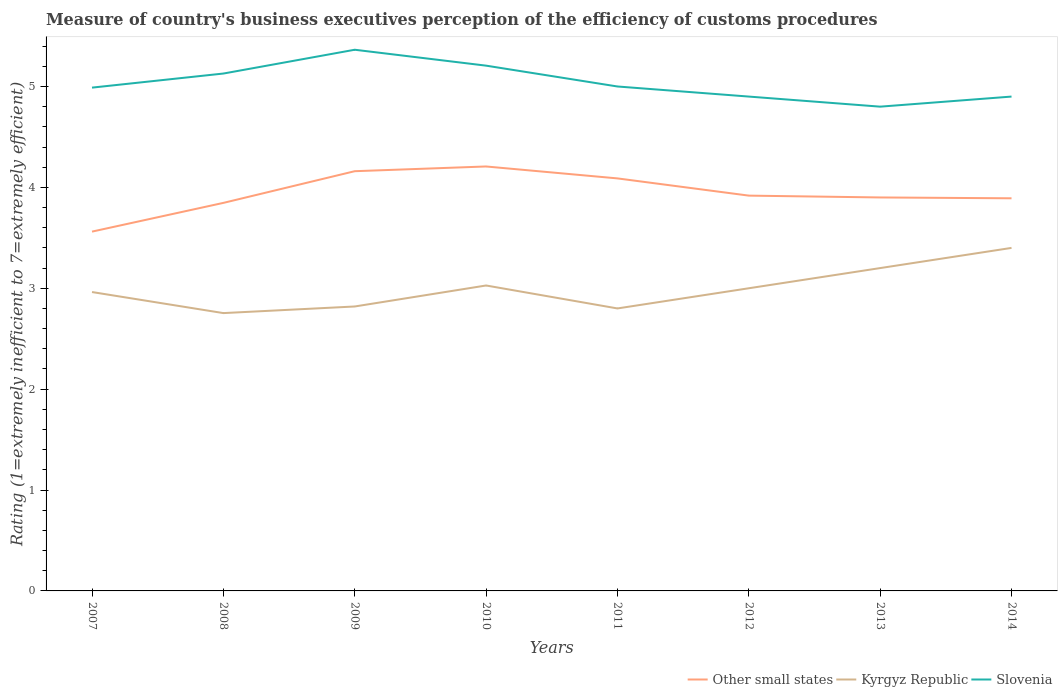How many different coloured lines are there?
Keep it short and to the point. 3. What is the total rating of the efficiency of customs procedure in Slovenia in the graph?
Keep it short and to the point. 0.31. What is the difference between the highest and the second highest rating of the efficiency of customs procedure in Other small states?
Provide a succinct answer. 0.65. Is the rating of the efficiency of customs procedure in Kyrgyz Republic strictly greater than the rating of the efficiency of customs procedure in Slovenia over the years?
Give a very brief answer. Yes. How many years are there in the graph?
Offer a very short reply. 8. Are the values on the major ticks of Y-axis written in scientific E-notation?
Provide a short and direct response. No. Does the graph contain any zero values?
Your answer should be very brief. No. Where does the legend appear in the graph?
Give a very brief answer. Bottom right. How are the legend labels stacked?
Offer a very short reply. Horizontal. What is the title of the graph?
Ensure brevity in your answer.  Measure of country's business executives perception of the efficiency of customs procedures. What is the label or title of the X-axis?
Provide a short and direct response. Years. What is the label or title of the Y-axis?
Provide a succinct answer. Rating (1=extremely inefficient to 7=extremely efficient). What is the Rating (1=extremely inefficient to 7=extremely efficient) of Other small states in 2007?
Your answer should be very brief. 3.56. What is the Rating (1=extremely inefficient to 7=extremely efficient) in Kyrgyz Republic in 2007?
Offer a terse response. 2.96. What is the Rating (1=extremely inefficient to 7=extremely efficient) in Slovenia in 2007?
Keep it short and to the point. 4.99. What is the Rating (1=extremely inefficient to 7=extremely efficient) in Other small states in 2008?
Provide a short and direct response. 3.85. What is the Rating (1=extremely inefficient to 7=extremely efficient) of Kyrgyz Republic in 2008?
Offer a terse response. 2.75. What is the Rating (1=extremely inefficient to 7=extremely efficient) of Slovenia in 2008?
Provide a short and direct response. 5.13. What is the Rating (1=extremely inefficient to 7=extremely efficient) of Other small states in 2009?
Your response must be concise. 4.16. What is the Rating (1=extremely inefficient to 7=extremely efficient) in Kyrgyz Republic in 2009?
Your answer should be compact. 2.82. What is the Rating (1=extremely inefficient to 7=extremely efficient) of Slovenia in 2009?
Make the answer very short. 5.36. What is the Rating (1=extremely inefficient to 7=extremely efficient) of Other small states in 2010?
Offer a terse response. 4.21. What is the Rating (1=extremely inefficient to 7=extremely efficient) of Kyrgyz Republic in 2010?
Your answer should be very brief. 3.03. What is the Rating (1=extremely inefficient to 7=extremely efficient) of Slovenia in 2010?
Give a very brief answer. 5.21. What is the Rating (1=extremely inefficient to 7=extremely efficient) in Other small states in 2011?
Give a very brief answer. 4.09. What is the Rating (1=extremely inefficient to 7=extremely efficient) in Kyrgyz Republic in 2011?
Offer a terse response. 2.8. What is the Rating (1=extremely inefficient to 7=extremely efficient) in Slovenia in 2011?
Give a very brief answer. 5. What is the Rating (1=extremely inefficient to 7=extremely efficient) in Other small states in 2012?
Your answer should be compact. 3.92. What is the Rating (1=extremely inefficient to 7=extremely efficient) of Slovenia in 2012?
Your response must be concise. 4.9. What is the Rating (1=extremely inefficient to 7=extremely efficient) in Other small states in 2013?
Keep it short and to the point. 3.9. What is the Rating (1=extremely inefficient to 7=extremely efficient) of Kyrgyz Republic in 2013?
Keep it short and to the point. 3.2. What is the Rating (1=extremely inefficient to 7=extremely efficient) of Slovenia in 2013?
Provide a succinct answer. 4.8. What is the Rating (1=extremely inefficient to 7=extremely efficient) of Other small states in 2014?
Keep it short and to the point. 3.89. Across all years, what is the maximum Rating (1=extremely inefficient to 7=extremely efficient) in Other small states?
Offer a very short reply. 4.21. Across all years, what is the maximum Rating (1=extremely inefficient to 7=extremely efficient) in Kyrgyz Republic?
Ensure brevity in your answer.  3.4. Across all years, what is the maximum Rating (1=extremely inefficient to 7=extremely efficient) of Slovenia?
Keep it short and to the point. 5.36. Across all years, what is the minimum Rating (1=extremely inefficient to 7=extremely efficient) in Other small states?
Make the answer very short. 3.56. Across all years, what is the minimum Rating (1=extremely inefficient to 7=extremely efficient) in Kyrgyz Republic?
Your answer should be very brief. 2.75. What is the total Rating (1=extremely inefficient to 7=extremely efficient) of Other small states in the graph?
Provide a short and direct response. 31.57. What is the total Rating (1=extremely inefficient to 7=extremely efficient) in Kyrgyz Republic in the graph?
Give a very brief answer. 23.96. What is the total Rating (1=extremely inefficient to 7=extremely efficient) of Slovenia in the graph?
Offer a terse response. 40.29. What is the difference between the Rating (1=extremely inefficient to 7=extremely efficient) in Other small states in 2007 and that in 2008?
Give a very brief answer. -0.28. What is the difference between the Rating (1=extremely inefficient to 7=extremely efficient) of Kyrgyz Republic in 2007 and that in 2008?
Provide a succinct answer. 0.21. What is the difference between the Rating (1=extremely inefficient to 7=extremely efficient) of Slovenia in 2007 and that in 2008?
Give a very brief answer. -0.14. What is the difference between the Rating (1=extremely inefficient to 7=extremely efficient) in Other small states in 2007 and that in 2009?
Your answer should be very brief. -0.6. What is the difference between the Rating (1=extremely inefficient to 7=extremely efficient) in Kyrgyz Republic in 2007 and that in 2009?
Make the answer very short. 0.14. What is the difference between the Rating (1=extremely inefficient to 7=extremely efficient) of Slovenia in 2007 and that in 2009?
Your response must be concise. -0.38. What is the difference between the Rating (1=extremely inefficient to 7=extremely efficient) of Other small states in 2007 and that in 2010?
Offer a terse response. -0.65. What is the difference between the Rating (1=extremely inefficient to 7=extremely efficient) in Kyrgyz Republic in 2007 and that in 2010?
Offer a very short reply. -0.06. What is the difference between the Rating (1=extremely inefficient to 7=extremely efficient) of Slovenia in 2007 and that in 2010?
Your response must be concise. -0.22. What is the difference between the Rating (1=extremely inefficient to 7=extremely efficient) in Other small states in 2007 and that in 2011?
Provide a succinct answer. -0.53. What is the difference between the Rating (1=extremely inefficient to 7=extremely efficient) of Kyrgyz Republic in 2007 and that in 2011?
Provide a short and direct response. 0.16. What is the difference between the Rating (1=extremely inefficient to 7=extremely efficient) in Slovenia in 2007 and that in 2011?
Offer a terse response. -0.01. What is the difference between the Rating (1=extremely inefficient to 7=extremely efficient) of Other small states in 2007 and that in 2012?
Provide a succinct answer. -0.36. What is the difference between the Rating (1=extremely inefficient to 7=extremely efficient) in Kyrgyz Republic in 2007 and that in 2012?
Offer a terse response. -0.04. What is the difference between the Rating (1=extremely inefficient to 7=extremely efficient) of Slovenia in 2007 and that in 2012?
Your answer should be very brief. 0.09. What is the difference between the Rating (1=extremely inefficient to 7=extremely efficient) of Other small states in 2007 and that in 2013?
Offer a very short reply. -0.34. What is the difference between the Rating (1=extremely inefficient to 7=extremely efficient) of Kyrgyz Republic in 2007 and that in 2013?
Make the answer very short. -0.24. What is the difference between the Rating (1=extremely inefficient to 7=extremely efficient) in Slovenia in 2007 and that in 2013?
Your answer should be very brief. 0.19. What is the difference between the Rating (1=extremely inefficient to 7=extremely efficient) of Other small states in 2007 and that in 2014?
Provide a succinct answer. -0.33. What is the difference between the Rating (1=extremely inefficient to 7=extremely efficient) in Kyrgyz Republic in 2007 and that in 2014?
Ensure brevity in your answer.  -0.44. What is the difference between the Rating (1=extremely inefficient to 7=extremely efficient) of Slovenia in 2007 and that in 2014?
Ensure brevity in your answer.  0.09. What is the difference between the Rating (1=extremely inefficient to 7=extremely efficient) in Other small states in 2008 and that in 2009?
Your answer should be very brief. -0.31. What is the difference between the Rating (1=extremely inefficient to 7=extremely efficient) of Kyrgyz Republic in 2008 and that in 2009?
Keep it short and to the point. -0.07. What is the difference between the Rating (1=extremely inefficient to 7=extremely efficient) in Slovenia in 2008 and that in 2009?
Keep it short and to the point. -0.24. What is the difference between the Rating (1=extremely inefficient to 7=extremely efficient) of Other small states in 2008 and that in 2010?
Provide a succinct answer. -0.36. What is the difference between the Rating (1=extremely inefficient to 7=extremely efficient) of Kyrgyz Republic in 2008 and that in 2010?
Offer a terse response. -0.27. What is the difference between the Rating (1=extremely inefficient to 7=extremely efficient) in Slovenia in 2008 and that in 2010?
Offer a very short reply. -0.08. What is the difference between the Rating (1=extremely inefficient to 7=extremely efficient) in Other small states in 2008 and that in 2011?
Your response must be concise. -0.24. What is the difference between the Rating (1=extremely inefficient to 7=extremely efficient) in Kyrgyz Republic in 2008 and that in 2011?
Provide a short and direct response. -0.05. What is the difference between the Rating (1=extremely inefficient to 7=extremely efficient) in Slovenia in 2008 and that in 2011?
Offer a very short reply. 0.13. What is the difference between the Rating (1=extremely inefficient to 7=extremely efficient) in Other small states in 2008 and that in 2012?
Offer a very short reply. -0.07. What is the difference between the Rating (1=extremely inefficient to 7=extremely efficient) in Kyrgyz Republic in 2008 and that in 2012?
Keep it short and to the point. -0.25. What is the difference between the Rating (1=extremely inefficient to 7=extremely efficient) of Slovenia in 2008 and that in 2012?
Give a very brief answer. 0.23. What is the difference between the Rating (1=extremely inefficient to 7=extremely efficient) in Other small states in 2008 and that in 2013?
Offer a terse response. -0.05. What is the difference between the Rating (1=extremely inefficient to 7=extremely efficient) in Kyrgyz Republic in 2008 and that in 2013?
Provide a short and direct response. -0.45. What is the difference between the Rating (1=extremely inefficient to 7=extremely efficient) in Slovenia in 2008 and that in 2013?
Your answer should be very brief. 0.33. What is the difference between the Rating (1=extremely inefficient to 7=extremely efficient) in Other small states in 2008 and that in 2014?
Give a very brief answer. -0.05. What is the difference between the Rating (1=extremely inefficient to 7=extremely efficient) of Kyrgyz Republic in 2008 and that in 2014?
Your response must be concise. -0.65. What is the difference between the Rating (1=extremely inefficient to 7=extremely efficient) in Slovenia in 2008 and that in 2014?
Keep it short and to the point. 0.23. What is the difference between the Rating (1=extremely inefficient to 7=extremely efficient) of Other small states in 2009 and that in 2010?
Ensure brevity in your answer.  -0.05. What is the difference between the Rating (1=extremely inefficient to 7=extremely efficient) of Kyrgyz Republic in 2009 and that in 2010?
Your answer should be compact. -0.21. What is the difference between the Rating (1=extremely inefficient to 7=extremely efficient) in Slovenia in 2009 and that in 2010?
Your response must be concise. 0.16. What is the difference between the Rating (1=extremely inefficient to 7=extremely efficient) in Other small states in 2009 and that in 2011?
Your response must be concise. 0.07. What is the difference between the Rating (1=extremely inefficient to 7=extremely efficient) in Kyrgyz Republic in 2009 and that in 2011?
Your response must be concise. 0.02. What is the difference between the Rating (1=extremely inefficient to 7=extremely efficient) of Slovenia in 2009 and that in 2011?
Ensure brevity in your answer.  0.36. What is the difference between the Rating (1=extremely inefficient to 7=extremely efficient) in Other small states in 2009 and that in 2012?
Ensure brevity in your answer.  0.24. What is the difference between the Rating (1=extremely inefficient to 7=extremely efficient) in Kyrgyz Republic in 2009 and that in 2012?
Ensure brevity in your answer.  -0.18. What is the difference between the Rating (1=extremely inefficient to 7=extremely efficient) in Slovenia in 2009 and that in 2012?
Offer a terse response. 0.46. What is the difference between the Rating (1=extremely inefficient to 7=extremely efficient) of Other small states in 2009 and that in 2013?
Your answer should be very brief. 0.26. What is the difference between the Rating (1=extremely inefficient to 7=extremely efficient) of Kyrgyz Republic in 2009 and that in 2013?
Keep it short and to the point. -0.38. What is the difference between the Rating (1=extremely inefficient to 7=extremely efficient) of Slovenia in 2009 and that in 2013?
Offer a terse response. 0.56. What is the difference between the Rating (1=extremely inefficient to 7=extremely efficient) of Other small states in 2009 and that in 2014?
Keep it short and to the point. 0.27. What is the difference between the Rating (1=extremely inefficient to 7=extremely efficient) in Kyrgyz Republic in 2009 and that in 2014?
Offer a terse response. -0.58. What is the difference between the Rating (1=extremely inefficient to 7=extremely efficient) of Slovenia in 2009 and that in 2014?
Provide a short and direct response. 0.46. What is the difference between the Rating (1=extremely inefficient to 7=extremely efficient) of Other small states in 2010 and that in 2011?
Ensure brevity in your answer.  0.12. What is the difference between the Rating (1=extremely inefficient to 7=extremely efficient) of Kyrgyz Republic in 2010 and that in 2011?
Ensure brevity in your answer.  0.23. What is the difference between the Rating (1=extremely inefficient to 7=extremely efficient) in Slovenia in 2010 and that in 2011?
Your answer should be very brief. 0.21. What is the difference between the Rating (1=extremely inefficient to 7=extremely efficient) in Other small states in 2010 and that in 2012?
Make the answer very short. 0.29. What is the difference between the Rating (1=extremely inefficient to 7=extremely efficient) of Kyrgyz Republic in 2010 and that in 2012?
Your answer should be compact. 0.03. What is the difference between the Rating (1=extremely inefficient to 7=extremely efficient) in Slovenia in 2010 and that in 2012?
Your answer should be very brief. 0.31. What is the difference between the Rating (1=extremely inefficient to 7=extremely efficient) in Other small states in 2010 and that in 2013?
Provide a short and direct response. 0.31. What is the difference between the Rating (1=extremely inefficient to 7=extremely efficient) in Kyrgyz Republic in 2010 and that in 2013?
Offer a terse response. -0.17. What is the difference between the Rating (1=extremely inefficient to 7=extremely efficient) of Slovenia in 2010 and that in 2013?
Offer a very short reply. 0.41. What is the difference between the Rating (1=extremely inefficient to 7=extremely efficient) of Other small states in 2010 and that in 2014?
Make the answer very short. 0.32. What is the difference between the Rating (1=extremely inefficient to 7=extremely efficient) of Kyrgyz Republic in 2010 and that in 2014?
Offer a terse response. -0.37. What is the difference between the Rating (1=extremely inefficient to 7=extremely efficient) in Slovenia in 2010 and that in 2014?
Offer a very short reply. 0.31. What is the difference between the Rating (1=extremely inefficient to 7=extremely efficient) of Other small states in 2011 and that in 2012?
Make the answer very short. 0.17. What is the difference between the Rating (1=extremely inefficient to 7=extremely efficient) in Other small states in 2011 and that in 2013?
Keep it short and to the point. 0.19. What is the difference between the Rating (1=extremely inefficient to 7=extremely efficient) in Other small states in 2011 and that in 2014?
Your answer should be compact. 0.2. What is the difference between the Rating (1=extremely inefficient to 7=extremely efficient) in Kyrgyz Republic in 2011 and that in 2014?
Provide a succinct answer. -0.6. What is the difference between the Rating (1=extremely inefficient to 7=extremely efficient) of Slovenia in 2011 and that in 2014?
Your answer should be very brief. 0.1. What is the difference between the Rating (1=extremely inefficient to 7=extremely efficient) of Other small states in 2012 and that in 2013?
Make the answer very short. 0.02. What is the difference between the Rating (1=extremely inefficient to 7=extremely efficient) in Slovenia in 2012 and that in 2013?
Offer a terse response. 0.1. What is the difference between the Rating (1=extremely inefficient to 7=extremely efficient) of Other small states in 2012 and that in 2014?
Your answer should be very brief. 0.03. What is the difference between the Rating (1=extremely inefficient to 7=extremely efficient) of Slovenia in 2012 and that in 2014?
Make the answer very short. 0. What is the difference between the Rating (1=extremely inefficient to 7=extremely efficient) in Other small states in 2013 and that in 2014?
Your answer should be very brief. 0.01. What is the difference between the Rating (1=extremely inefficient to 7=extremely efficient) of Slovenia in 2013 and that in 2014?
Your answer should be very brief. -0.1. What is the difference between the Rating (1=extremely inefficient to 7=extremely efficient) in Other small states in 2007 and the Rating (1=extremely inefficient to 7=extremely efficient) in Kyrgyz Republic in 2008?
Provide a succinct answer. 0.81. What is the difference between the Rating (1=extremely inefficient to 7=extremely efficient) of Other small states in 2007 and the Rating (1=extremely inefficient to 7=extremely efficient) of Slovenia in 2008?
Offer a very short reply. -1.57. What is the difference between the Rating (1=extremely inefficient to 7=extremely efficient) in Kyrgyz Republic in 2007 and the Rating (1=extremely inefficient to 7=extremely efficient) in Slovenia in 2008?
Ensure brevity in your answer.  -2.17. What is the difference between the Rating (1=extremely inefficient to 7=extremely efficient) in Other small states in 2007 and the Rating (1=extremely inefficient to 7=extremely efficient) in Kyrgyz Republic in 2009?
Give a very brief answer. 0.74. What is the difference between the Rating (1=extremely inefficient to 7=extremely efficient) of Other small states in 2007 and the Rating (1=extremely inefficient to 7=extremely efficient) of Slovenia in 2009?
Your answer should be very brief. -1.8. What is the difference between the Rating (1=extremely inefficient to 7=extremely efficient) of Kyrgyz Republic in 2007 and the Rating (1=extremely inefficient to 7=extremely efficient) of Slovenia in 2009?
Offer a very short reply. -2.4. What is the difference between the Rating (1=extremely inefficient to 7=extremely efficient) of Other small states in 2007 and the Rating (1=extremely inefficient to 7=extremely efficient) of Kyrgyz Republic in 2010?
Make the answer very short. 0.53. What is the difference between the Rating (1=extremely inefficient to 7=extremely efficient) of Other small states in 2007 and the Rating (1=extremely inefficient to 7=extremely efficient) of Slovenia in 2010?
Provide a short and direct response. -1.65. What is the difference between the Rating (1=extremely inefficient to 7=extremely efficient) in Kyrgyz Republic in 2007 and the Rating (1=extremely inefficient to 7=extremely efficient) in Slovenia in 2010?
Your answer should be very brief. -2.24. What is the difference between the Rating (1=extremely inefficient to 7=extremely efficient) of Other small states in 2007 and the Rating (1=extremely inefficient to 7=extremely efficient) of Kyrgyz Republic in 2011?
Offer a terse response. 0.76. What is the difference between the Rating (1=extremely inefficient to 7=extremely efficient) in Other small states in 2007 and the Rating (1=extremely inefficient to 7=extremely efficient) in Slovenia in 2011?
Make the answer very short. -1.44. What is the difference between the Rating (1=extremely inefficient to 7=extremely efficient) in Kyrgyz Republic in 2007 and the Rating (1=extremely inefficient to 7=extremely efficient) in Slovenia in 2011?
Ensure brevity in your answer.  -2.04. What is the difference between the Rating (1=extremely inefficient to 7=extremely efficient) in Other small states in 2007 and the Rating (1=extremely inefficient to 7=extremely efficient) in Kyrgyz Republic in 2012?
Make the answer very short. 0.56. What is the difference between the Rating (1=extremely inefficient to 7=extremely efficient) of Other small states in 2007 and the Rating (1=extremely inefficient to 7=extremely efficient) of Slovenia in 2012?
Give a very brief answer. -1.34. What is the difference between the Rating (1=extremely inefficient to 7=extremely efficient) of Kyrgyz Republic in 2007 and the Rating (1=extremely inefficient to 7=extremely efficient) of Slovenia in 2012?
Keep it short and to the point. -1.94. What is the difference between the Rating (1=extremely inefficient to 7=extremely efficient) of Other small states in 2007 and the Rating (1=extremely inefficient to 7=extremely efficient) of Kyrgyz Republic in 2013?
Offer a terse response. 0.36. What is the difference between the Rating (1=extremely inefficient to 7=extremely efficient) in Other small states in 2007 and the Rating (1=extremely inefficient to 7=extremely efficient) in Slovenia in 2013?
Give a very brief answer. -1.24. What is the difference between the Rating (1=extremely inefficient to 7=extremely efficient) in Kyrgyz Republic in 2007 and the Rating (1=extremely inefficient to 7=extremely efficient) in Slovenia in 2013?
Provide a succinct answer. -1.84. What is the difference between the Rating (1=extremely inefficient to 7=extremely efficient) in Other small states in 2007 and the Rating (1=extremely inefficient to 7=extremely efficient) in Kyrgyz Republic in 2014?
Provide a succinct answer. 0.16. What is the difference between the Rating (1=extremely inefficient to 7=extremely efficient) of Other small states in 2007 and the Rating (1=extremely inefficient to 7=extremely efficient) of Slovenia in 2014?
Offer a very short reply. -1.34. What is the difference between the Rating (1=extremely inefficient to 7=extremely efficient) in Kyrgyz Republic in 2007 and the Rating (1=extremely inefficient to 7=extremely efficient) in Slovenia in 2014?
Ensure brevity in your answer.  -1.94. What is the difference between the Rating (1=extremely inefficient to 7=extremely efficient) of Other small states in 2008 and the Rating (1=extremely inefficient to 7=extremely efficient) of Kyrgyz Republic in 2009?
Your response must be concise. 1.03. What is the difference between the Rating (1=extremely inefficient to 7=extremely efficient) of Other small states in 2008 and the Rating (1=extremely inefficient to 7=extremely efficient) of Slovenia in 2009?
Provide a succinct answer. -1.52. What is the difference between the Rating (1=extremely inefficient to 7=extremely efficient) of Kyrgyz Republic in 2008 and the Rating (1=extremely inefficient to 7=extremely efficient) of Slovenia in 2009?
Your answer should be very brief. -2.61. What is the difference between the Rating (1=extremely inefficient to 7=extremely efficient) of Other small states in 2008 and the Rating (1=extremely inefficient to 7=extremely efficient) of Kyrgyz Republic in 2010?
Provide a succinct answer. 0.82. What is the difference between the Rating (1=extremely inefficient to 7=extremely efficient) in Other small states in 2008 and the Rating (1=extremely inefficient to 7=extremely efficient) in Slovenia in 2010?
Keep it short and to the point. -1.36. What is the difference between the Rating (1=extremely inefficient to 7=extremely efficient) of Kyrgyz Republic in 2008 and the Rating (1=extremely inefficient to 7=extremely efficient) of Slovenia in 2010?
Keep it short and to the point. -2.45. What is the difference between the Rating (1=extremely inefficient to 7=extremely efficient) in Other small states in 2008 and the Rating (1=extremely inefficient to 7=extremely efficient) in Kyrgyz Republic in 2011?
Offer a very short reply. 1.05. What is the difference between the Rating (1=extremely inefficient to 7=extremely efficient) in Other small states in 2008 and the Rating (1=extremely inefficient to 7=extremely efficient) in Slovenia in 2011?
Provide a succinct answer. -1.15. What is the difference between the Rating (1=extremely inefficient to 7=extremely efficient) in Kyrgyz Republic in 2008 and the Rating (1=extremely inefficient to 7=extremely efficient) in Slovenia in 2011?
Provide a succinct answer. -2.25. What is the difference between the Rating (1=extremely inefficient to 7=extremely efficient) in Other small states in 2008 and the Rating (1=extremely inefficient to 7=extremely efficient) in Kyrgyz Republic in 2012?
Provide a short and direct response. 0.85. What is the difference between the Rating (1=extremely inefficient to 7=extremely efficient) of Other small states in 2008 and the Rating (1=extremely inefficient to 7=extremely efficient) of Slovenia in 2012?
Your response must be concise. -1.05. What is the difference between the Rating (1=extremely inefficient to 7=extremely efficient) in Kyrgyz Republic in 2008 and the Rating (1=extremely inefficient to 7=extremely efficient) in Slovenia in 2012?
Your response must be concise. -2.15. What is the difference between the Rating (1=extremely inefficient to 7=extremely efficient) of Other small states in 2008 and the Rating (1=extremely inefficient to 7=extremely efficient) of Kyrgyz Republic in 2013?
Provide a succinct answer. 0.65. What is the difference between the Rating (1=extremely inefficient to 7=extremely efficient) in Other small states in 2008 and the Rating (1=extremely inefficient to 7=extremely efficient) in Slovenia in 2013?
Give a very brief answer. -0.95. What is the difference between the Rating (1=extremely inefficient to 7=extremely efficient) in Kyrgyz Republic in 2008 and the Rating (1=extremely inefficient to 7=extremely efficient) in Slovenia in 2013?
Your answer should be very brief. -2.05. What is the difference between the Rating (1=extremely inefficient to 7=extremely efficient) in Other small states in 2008 and the Rating (1=extremely inefficient to 7=extremely efficient) in Kyrgyz Republic in 2014?
Your response must be concise. 0.45. What is the difference between the Rating (1=extremely inefficient to 7=extremely efficient) of Other small states in 2008 and the Rating (1=extremely inefficient to 7=extremely efficient) of Slovenia in 2014?
Ensure brevity in your answer.  -1.05. What is the difference between the Rating (1=extremely inefficient to 7=extremely efficient) of Kyrgyz Republic in 2008 and the Rating (1=extremely inefficient to 7=extremely efficient) of Slovenia in 2014?
Ensure brevity in your answer.  -2.15. What is the difference between the Rating (1=extremely inefficient to 7=extremely efficient) in Other small states in 2009 and the Rating (1=extremely inefficient to 7=extremely efficient) in Kyrgyz Republic in 2010?
Your answer should be compact. 1.13. What is the difference between the Rating (1=extremely inefficient to 7=extremely efficient) in Other small states in 2009 and the Rating (1=extremely inefficient to 7=extremely efficient) in Slovenia in 2010?
Make the answer very short. -1.05. What is the difference between the Rating (1=extremely inefficient to 7=extremely efficient) of Kyrgyz Republic in 2009 and the Rating (1=extremely inefficient to 7=extremely efficient) of Slovenia in 2010?
Give a very brief answer. -2.39. What is the difference between the Rating (1=extremely inefficient to 7=extremely efficient) of Other small states in 2009 and the Rating (1=extremely inefficient to 7=extremely efficient) of Kyrgyz Republic in 2011?
Give a very brief answer. 1.36. What is the difference between the Rating (1=extremely inefficient to 7=extremely efficient) in Other small states in 2009 and the Rating (1=extremely inefficient to 7=extremely efficient) in Slovenia in 2011?
Offer a terse response. -0.84. What is the difference between the Rating (1=extremely inefficient to 7=extremely efficient) of Kyrgyz Republic in 2009 and the Rating (1=extremely inefficient to 7=extremely efficient) of Slovenia in 2011?
Provide a succinct answer. -2.18. What is the difference between the Rating (1=extremely inefficient to 7=extremely efficient) of Other small states in 2009 and the Rating (1=extremely inefficient to 7=extremely efficient) of Kyrgyz Republic in 2012?
Provide a succinct answer. 1.16. What is the difference between the Rating (1=extremely inefficient to 7=extremely efficient) of Other small states in 2009 and the Rating (1=extremely inefficient to 7=extremely efficient) of Slovenia in 2012?
Keep it short and to the point. -0.74. What is the difference between the Rating (1=extremely inefficient to 7=extremely efficient) of Kyrgyz Republic in 2009 and the Rating (1=extremely inefficient to 7=extremely efficient) of Slovenia in 2012?
Offer a very short reply. -2.08. What is the difference between the Rating (1=extremely inefficient to 7=extremely efficient) in Other small states in 2009 and the Rating (1=extremely inefficient to 7=extremely efficient) in Kyrgyz Republic in 2013?
Provide a succinct answer. 0.96. What is the difference between the Rating (1=extremely inefficient to 7=extremely efficient) of Other small states in 2009 and the Rating (1=extremely inefficient to 7=extremely efficient) of Slovenia in 2013?
Your answer should be compact. -0.64. What is the difference between the Rating (1=extremely inefficient to 7=extremely efficient) in Kyrgyz Republic in 2009 and the Rating (1=extremely inefficient to 7=extremely efficient) in Slovenia in 2013?
Provide a succinct answer. -1.98. What is the difference between the Rating (1=extremely inefficient to 7=extremely efficient) in Other small states in 2009 and the Rating (1=extremely inefficient to 7=extremely efficient) in Kyrgyz Republic in 2014?
Your answer should be very brief. 0.76. What is the difference between the Rating (1=extremely inefficient to 7=extremely efficient) in Other small states in 2009 and the Rating (1=extremely inefficient to 7=extremely efficient) in Slovenia in 2014?
Your response must be concise. -0.74. What is the difference between the Rating (1=extremely inefficient to 7=extremely efficient) in Kyrgyz Republic in 2009 and the Rating (1=extremely inefficient to 7=extremely efficient) in Slovenia in 2014?
Give a very brief answer. -2.08. What is the difference between the Rating (1=extremely inefficient to 7=extremely efficient) of Other small states in 2010 and the Rating (1=extremely inefficient to 7=extremely efficient) of Kyrgyz Republic in 2011?
Your answer should be compact. 1.41. What is the difference between the Rating (1=extremely inefficient to 7=extremely efficient) of Other small states in 2010 and the Rating (1=extremely inefficient to 7=extremely efficient) of Slovenia in 2011?
Offer a very short reply. -0.79. What is the difference between the Rating (1=extremely inefficient to 7=extremely efficient) in Kyrgyz Republic in 2010 and the Rating (1=extremely inefficient to 7=extremely efficient) in Slovenia in 2011?
Make the answer very short. -1.97. What is the difference between the Rating (1=extremely inefficient to 7=extremely efficient) in Other small states in 2010 and the Rating (1=extremely inefficient to 7=extremely efficient) in Kyrgyz Republic in 2012?
Your answer should be compact. 1.21. What is the difference between the Rating (1=extremely inefficient to 7=extremely efficient) in Other small states in 2010 and the Rating (1=extremely inefficient to 7=extremely efficient) in Slovenia in 2012?
Provide a succinct answer. -0.69. What is the difference between the Rating (1=extremely inefficient to 7=extremely efficient) of Kyrgyz Republic in 2010 and the Rating (1=extremely inefficient to 7=extremely efficient) of Slovenia in 2012?
Your answer should be very brief. -1.87. What is the difference between the Rating (1=extremely inefficient to 7=extremely efficient) in Other small states in 2010 and the Rating (1=extremely inefficient to 7=extremely efficient) in Kyrgyz Republic in 2013?
Offer a terse response. 1.01. What is the difference between the Rating (1=extremely inefficient to 7=extremely efficient) of Other small states in 2010 and the Rating (1=extremely inefficient to 7=extremely efficient) of Slovenia in 2013?
Your answer should be very brief. -0.59. What is the difference between the Rating (1=extremely inefficient to 7=extremely efficient) of Kyrgyz Republic in 2010 and the Rating (1=extremely inefficient to 7=extremely efficient) of Slovenia in 2013?
Your answer should be compact. -1.77. What is the difference between the Rating (1=extremely inefficient to 7=extremely efficient) in Other small states in 2010 and the Rating (1=extremely inefficient to 7=extremely efficient) in Kyrgyz Republic in 2014?
Give a very brief answer. 0.81. What is the difference between the Rating (1=extremely inefficient to 7=extremely efficient) of Other small states in 2010 and the Rating (1=extremely inefficient to 7=extremely efficient) of Slovenia in 2014?
Provide a short and direct response. -0.69. What is the difference between the Rating (1=extremely inefficient to 7=extremely efficient) of Kyrgyz Republic in 2010 and the Rating (1=extremely inefficient to 7=extremely efficient) of Slovenia in 2014?
Your answer should be very brief. -1.87. What is the difference between the Rating (1=extremely inefficient to 7=extremely efficient) of Other small states in 2011 and the Rating (1=extremely inefficient to 7=extremely efficient) of Kyrgyz Republic in 2012?
Ensure brevity in your answer.  1.09. What is the difference between the Rating (1=extremely inefficient to 7=extremely efficient) of Other small states in 2011 and the Rating (1=extremely inefficient to 7=extremely efficient) of Slovenia in 2012?
Provide a succinct answer. -0.81. What is the difference between the Rating (1=extremely inefficient to 7=extremely efficient) of Other small states in 2011 and the Rating (1=extremely inefficient to 7=extremely efficient) of Slovenia in 2013?
Ensure brevity in your answer.  -0.71. What is the difference between the Rating (1=extremely inefficient to 7=extremely efficient) of Other small states in 2011 and the Rating (1=extremely inefficient to 7=extremely efficient) of Kyrgyz Republic in 2014?
Give a very brief answer. 0.69. What is the difference between the Rating (1=extremely inefficient to 7=extremely efficient) of Other small states in 2011 and the Rating (1=extremely inefficient to 7=extremely efficient) of Slovenia in 2014?
Ensure brevity in your answer.  -0.81. What is the difference between the Rating (1=extremely inefficient to 7=extremely efficient) of Other small states in 2012 and the Rating (1=extremely inefficient to 7=extremely efficient) of Kyrgyz Republic in 2013?
Your answer should be compact. 0.72. What is the difference between the Rating (1=extremely inefficient to 7=extremely efficient) of Other small states in 2012 and the Rating (1=extremely inefficient to 7=extremely efficient) of Slovenia in 2013?
Your answer should be very brief. -0.88. What is the difference between the Rating (1=extremely inefficient to 7=extremely efficient) of Kyrgyz Republic in 2012 and the Rating (1=extremely inefficient to 7=extremely efficient) of Slovenia in 2013?
Offer a terse response. -1.8. What is the difference between the Rating (1=extremely inefficient to 7=extremely efficient) of Other small states in 2012 and the Rating (1=extremely inefficient to 7=extremely efficient) of Kyrgyz Republic in 2014?
Offer a very short reply. 0.52. What is the difference between the Rating (1=extremely inefficient to 7=extremely efficient) of Other small states in 2012 and the Rating (1=extremely inefficient to 7=extremely efficient) of Slovenia in 2014?
Your answer should be compact. -0.98. What is the difference between the Rating (1=extremely inefficient to 7=extremely efficient) in Kyrgyz Republic in 2012 and the Rating (1=extremely inefficient to 7=extremely efficient) in Slovenia in 2014?
Keep it short and to the point. -1.9. What is the difference between the Rating (1=extremely inefficient to 7=extremely efficient) in Other small states in 2013 and the Rating (1=extremely inefficient to 7=extremely efficient) in Kyrgyz Republic in 2014?
Ensure brevity in your answer.  0.5. What is the difference between the Rating (1=extremely inefficient to 7=extremely efficient) in Other small states in 2013 and the Rating (1=extremely inefficient to 7=extremely efficient) in Slovenia in 2014?
Offer a terse response. -1. What is the difference between the Rating (1=extremely inefficient to 7=extremely efficient) in Kyrgyz Republic in 2013 and the Rating (1=extremely inefficient to 7=extremely efficient) in Slovenia in 2014?
Give a very brief answer. -1.7. What is the average Rating (1=extremely inefficient to 7=extremely efficient) of Other small states per year?
Keep it short and to the point. 3.95. What is the average Rating (1=extremely inefficient to 7=extremely efficient) in Kyrgyz Republic per year?
Provide a short and direct response. 3. What is the average Rating (1=extremely inefficient to 7=extremely efficient) of Slovenia per year?
Your response must be concise. 5.04. In the year 2007, what is the difference between the Rating (1=extremely inefficient to 7=extremely efficient) of Other small states and Rating (1=extremely inefficient to 7=extremely efficient) of Kyrgyz Republic?
Provide a succinct answer. 0.6. In the year 2007, what is the difference between the Rating (1=extremely inefficient to 7=extremely efficient) in Other small states and Rating (1=extremely inefficient to 7=extremely efficient) in Slovenia?
Offer a terse response. -1.43. In the year 2007, what is the difference between the Rating (1=extremely inefficient to 7=extremely efficient) of Kyrgyz Republic and Rating (1=extremely inefficient to 7=extremely efficient) of Slovenia?
Ensure brevity in your answer.  -2.03. In the year 2008, what is the difference between the Rating (1=extremely inefficient to 7=extremely efficient) of Other small states and Rating (1=extremely inefficient to 7=extremely efficient) of Kyrgyz Republic?
Your answer should be very brief. 1.09. In the year 2008, what is the difference between the Rating (1=extremely inefficient to 7=extremely efficient) in Other small states and Rating (1=extremely inefficient to 7=extremely efficient) in Slovenia?
Provide a succinct answer. -1.28. In the year 2008, what is the difference between the Rating (1=extremely inefficient to 7=extremely efficient) of Kyrgyz Republic and Rating (1=extremely inefficient to 7=extremely efficient) of Slovenia?
Provide a short and direct response. -2.37. In the year 2009, what is the difference between the Rating (1=extremely inefficient to 7=extremely efficient) in Other small states and Rating (1=extremely inefficient to 7=extremely efficient) in Kyrgyz Republic?
Provide a succinct answer. 1.34. In the year 2009, what is the difference between the Rating (1=extremely inefficient to 7=extremely efficient) of Other small states and Rating (1=extremely inefficient to 7=extremely efficient) of Slovenia?
Offer a terse response. -1.2. In the year 2009, what is the difference between the Rating (1=extremely inefficient to 7=extremely efficient) of Kyrgyz Republic and Rating (1=extremely inefficient to 7=extremely efficient) of Slovenia?
Your response must be concise. -2.54. In the year 2010, what is the difference between the Rating (1=extremely inefficient to 7=extremely efficient) in Other small states and Rating (1=extremely inefficient to 7=extremely efficient) in Kyrgyz Republic?
Provide a succinct answer. 1.18. In the year 2010, what is the difference between the Rating (1=extremely inefficient to 7=extremely efficient) of Other small states and Rating (1=extremely inefficient to 7=extremely efficient) of Slovenia?
Make the answer very short. -1. In the year 2010, what is the difference between the Rating (1=extremely inefficient to 7=extremely efficient) in Kyrgyz Republic and Rating (1=extremely inefficient to 7=extremely efficient) in Slovenia?
Provide a succinct answer. -2.18. In the year 2011, what is the difference between the Rating (1=extremely inefficient to 7=extremely efficient) of Other small states and Rating (1=extremely inefficient to 7=extremely efficient) of Kyrgyz Republic?
Offer a terse response. 1.29. In the year 2011, what is the difference between the Rating (1=extremely inefficient to 7=extremely efficient) of Other small states and Rating (1=extremely inefficient to 7=extremely efficient) of Slovenia?
Make the answer very short. -0.91. In the year 2012, what is the difference between the Rating (1=extremely inefficient to 7=extremely efficient) in Other small states and Rating (1=extremely inefficient to 7=extremely efficient) in Kyrgyz Republic?
Keep it short and to the point. 0.92. In the year 2012, what is the difference between the Rating (1=extremely inefficient to 7=extremely efficient) in Other small states and Rating (1=extremely inefficient to 7=extremely efficient) in Slovenia?
Your response must be concise. -0.98. In the year 2013, what is the difference between the Rating (1=extremely inefficient to 7=extremely efficient) in Other small states and Rating (1=extremely inefficient to 7=extremely efficient) in Kyrgyz Republic?
Your answer should be very brief. 0.7. In the year 2013, what is the difference between the Rating (1=extremely inefficient to 7=extremely efficient) of Kyrgyz Republic and Rating (1=extremely inefficient to 7=extremely efficient) of Slovenia?
Your response must be concise. -1.6. In the year 2014, what is the difference between the Rating (1=extremely inefficient to 7=extremely efficient) in Other small states and Rating (1=extremely inefficient to 7=extremely efficient) in Kyrgyz Republic?
Your response must be concise. 0.49. In the year 2014, what is the difference between the Rating (1=extremely inefficient to 7=extremely efficient) of Other small states and Rating (1=extremely inefficient to 7=extremely efficient) of Slovenia?
Ensure brevity in your answer.  -1.01. What is the ratio of the Rating (1=extremely inefficient to 7=extremely efficient) in Other small states in 2007 to that in 2008?
Your response must be concise. 0.93. What is the ratio of the Rating (1=extremely inefficient to 7=extremely efficient) of Kyrgyz Republic in 2007 to that in 2008?
Offer a very short reply. 1.08. What is the ratio of the Rating (1=extremely inefficient to 7=extremely efficient) of Slovenia in 2007 to that in 2008?
Offer a very short reply. 0.97. What is the ratio of the Rating (1=extremely inefficient to 7=extremely efficient) of Other small states in 2007 to that in 2009?
Your response must be concise. 0.86. What is the ratio of the Rating (1=extremely inefficient to 7=extremely efficient) in Kyrgyz Republic in 2007 to that in 2009?
Provide a short and direct response. 1.05. What is the ratio of the Rating (1=extremely inefficient to 7=extremely efficient) of Other small states in 2007 to that in 2010?
Provide a succinct answer. 0.85. What is the ratio of the Rating (1=extremely inefficient to 7=extremely efficient) of Kyrgyz Republic in 2007 to that in 2010?
Provide a succinct answer. 0.98. What is the ratio of the Rating (1=extremely inefficient to 7=extremely efficient) of Slovenia in 2007 to that in 2010?
Make the answer very short. 0.96. What is the ratio of the Rating (1=extremely inefficient to 7=extremely efficient) of Other small states in 2007 to that in 2011?
Offer a very short reply. 0.87. What is the ratio of the Rating (1=extremely inefficient to 7=extremely efficient) in Kyrgyz Republic in 2007 to that in 2011?
Offer a very short reply. 1.06. What is the ratio of the Rating (1=extremely inefficient to 7=extremely efficient) in Slovenia in 2007 to that in 2011?
Your response must be concise. 1. What is the ratio of the Rating (1=extremely inefficient to 7=extremely efficient) in Other small states in 2007 to that in 2012?
Provide a short and direct response. 0.91. What is the ratio of the Rating (1=extremely inefficient to 7=extremely efficient) in Kyrgyz Republic in 2007 to that in 2012?
Provide a short and direct response. 0.99. What is the ratio of the Rating (1=extremely inefficient to 7=extremely efficient) of Slovenia in 2007 to that in 2012?
Make the answer very short. 1.02. What is the ratio of the Rating (1=extremely inefficient to 7=extremely efficient) in Other small states in 2007 to that in 2013?
Make the answer very short. 0.91. What is the ratio of the Rating (1=extremely inefficient to 7=extremely efficient) in Kyrgyz Republic in 2007 to that in 2013?
Give a very brief answer. 0.93. What is the ratio of the Rating (1=extremely inefficient to 7=extremely efficient) in Slovenia in 2007 to that in 2013?
Your answer should be compact. 1.04. What is the ratio of the Rating (1=extremely inefficient to 7=extremely efficient) of Other small states in 2007 to that in 2014?
Provide a succinct answer. 0.92. What is the ratio of the Rating (1=extremely inefficient to 7=extremely efficient) of Kyrgyz Republic in 2007 to that in 2014?
Your answer should be very brief. 0.87. What is the ratio of the Rating (1=extremely inefficient to 7=extremely efficient) in Slovenia in 2007 to that in 2014?
Offer a terse response. 1.02. What is the ratio of the Rating (1=extremely inefficient to 7=extremely efficient) in Other small states in 2008 to that in 2009?
Give a very brief answer. 0.92. What is the ratio of the Rating (1=extremely inefficient to 7=extremely efficient) of Kyrgyz Republic in 2008 to that in 2009?
Offer a terse response. 0.98. What is the ratio of the Rating (1=extremely inefficient to 7=extremely efficient) of Slovenia in 2008 to that in 2009?
Keep it short and to the point. 0.96. What is the ratio of the Rating (1=extremely inefficient to 7=extremely efficient) of Other small states in 2008 to that in 2010?
Your answer should be compact. 0.91. What is the ratio of the Rating (1=extremely inefficient to 7=extremely efficient) in Kyrgyz Republic in 2008 to that in 2010?
Your answer should be compact. 0.91. What is the ratio of the Rating (1=extremely inefficient to 7=extremely efficient) of Slovenia in 2008 to that in 2010?
Make the answer very short. 0.98. What is the ratio of the Rating (1=extremely inefficient to 7=extremely efficient) of Other small states in 2008 to that in 2011?
Give a very brief answer. 0.94. What is the ratio of the Rating (1=extremely inefficient to 7=extremely efficient) in Kyrgyz Republic in 2008 to that in 2011?
Your answer should be very brief. 0.98. What is the ratio of the Rating (1=extremely inefficient to 7=extremely efficient) of Slovenia in 2008 to that in 2011?
Your answer should be compact. 1.03. What is the ratio of the Rating (1=extremely inefficient to 7=extremely efficient) in Other small states in 2008 to that in 2012?
Your answer should be compact. 0.98. What is the ratio of the Rating (1=extremely inefficient to 7=extremely efficient) in Kyrgyz Republic in 2008 to that in 2012?
Make the answer very short. 0.92. What is the ratio of the Rating (1=extremely inefficient to 7=extremely efficient) in Slovenia in 2008 to that in 2012?
Provide a succinct answer. 1.05. What is the ratio of the Rating (1=extremely inefficient to 7=extremely efficient) in Other small states in 2008 to that in 2013?
Your answer should be compact. 0.99. What is the ratio of the Rating (1=extremely inefficient to 7=extremely efficient) in Kyrgyz Republic in 2008 to that in 2013?
Make the answer very short. 0.86. What is the ratio of the Rating (1=extremely inefficient to 7=extremely efficient) in Slovenia in 2008 to that in 2013?
Offer a very short reply. 1.07. What is the ratio of the Rating (1=extremely inefficient to 7=extremely efficient) in Other small states in 2008 to that in 2014?
Ensure brevity in your answer.  0.99. What is the ratio of the Rating (1=extremely inefficient to 7=extremely efficient) of Kyrgyz Republic in 2008 to that in 2014?
Give a very brief answer. 0.81. What is the ratio of the Rating (1=extremely inefficient to 7=extremely efficient) in Slovenia in 2008 to that in 2014?
Your answer should be very brief. 1.05. What is the ratio of the Rating (1=extremely inefficient to 7=extremely efficient) of Other small states in 2009 to that in 2010?
Your answer should be very brief. 0.99. What is the ratio of the Rating (1=extremely inefficient to 7=extremely efficient) of Kyrgyz Republic in 2009 to that in 2010?
Provide a short and direct response. 0.93. What is the ratio of the Rating (1=extremely inefficient to 7=extremely efficient) of Slovenia in 2009 to that in 2010?
Make the answer very short. 1.03. What is the ratio of the Rating (1=extremely inefficient to 7=extremely efficient) in Other small states in 2009 to that in 2011?
Your answer should be compact. 1.02. What is the ratio of the Rating (1=extremely inefficient to 7=extremely efficient) in Slovenia in 2009 to that in 2011?
Provide a succinct answer. 1.07. What is the ratio of the Rating (1=extremely inefficient to 7=extremely efficient) of Other small states in 2009 to that in 2012?
Offer a very short reply. 1.06. What is the ratio of the Rating (1=extremely inefficient to 7=extremely efficient) in Kyrgyz Republic in 2009 to that in 2012?
Ensure brevity in your answer.  0.94. What is the ratio of the Rating (1=extremely inefficient to 7=extremely efficient) of Slovenia in 2009 to that in 2012?
Ensure brevity in your answer.  1.09. What is the ratio of the Rating (1=extremely inefficient to 7=extremely efficient) in Other small states in 2009 to that in 2013?
Your answer should be very brief. 1.07. What is the ratio of the Rating (1=extremely inefficient to 7=extremely efficient) of Kyrgyz Republic in 2009 to that in 2013?
Your response must be concise. 0.88. What is the ratio of the Rating (1=extremely inefficient to 7=extremely efficient) of Slovenia in 2009 to that in 2013?
Provide a short and direct response. 1.12. What is the ratio of the Rating (1=extremely inefficient to 7=extremely efficient) in Other small states in 2009 to that in 2014?
Keep it short and to the point. 1.07. What is the ratio of the Rating (1=extremely inefficient to 7=extremely efficient) in Kyrgyz Republic in 2009 to that in 2014?
Give a very brief answer. 0.83. What is the ratio of the Rating (1=extremely inefficient to 7=extremely efficient) in Slovenia in 2009 to that in 2014?
Offer a very short reply. 1.09. What is the ratio of the Rating (1=extremely inefficient to 7=extremely efficient) in Other small states in 2010 to that in 2011?
Offer a terse response. 1.03. What is the ratio of the Rating (1=extremely inefficient to 7=extremely efficient) of Kyrgyz Republic in 2010 to that in 2011?
Offer a terse response. 1.08. What is the ratio of the Rating (1=extremely inefficient to 7=extremely efficient) of Slovenia in 2010 to that in 2011?
Provide a succinct answer. 1.04. What is the ratio of the Rating (1=extremely inefficient to 7=extremely efficient) of Other small states in 2010 to that in 2012?
Offer a terse response. 1.07. What is the ratio of the Rating (1=extremely inefficient to 7=extremely efficient) of Kyrgyz Republic in 2010 to that in 2012?
Offer a terse response. 1.01. What is the ratio of the Rating (1=extremely inefficient to 7=extremely efficient) in Other small states in 2010 to that in 2013?
Give a very brief answer. 1.08. What is the ratio of the Rating (1=extremely inefficient to 7=extremely efficient) in Kyrgyz Republic in 2010 to that in 2013?
Offer a terse response. 0.95. What is the ratio of the Rating (1=extremely inefficient to 7=extremely efficient) of Slovenia in 2010 to that in 2013?
Your answer should be compact. 1.08. What is the ratio of the Rating (1=extremely inefficient to 7=extremely efficient) of Other small states in 2010 to that in 2014?
Your response must be concise. 1.08. What is the ratio of the Rating (1=extremely inefficient to 7=extremely efficient) of Kyrgyz Republic in 2010 to that in 2014?
Provide a succinct answer. 0.89. What is the ratio of the Rating (1=extremely inefficient to 7=extremely efficient) of Slovenia in 2010 to that in 2014?
Provide a short and direct response. 1.06. What is the ratio of the Rating (1=extremely inefficient to 7=extremely efficient) of Other small states in 2011 to that in 2012?
Your answer should be very brief. 1.04. What is the ratio of the Rating (1=extremely inefficient to 7=extremely efficient) in Slovenia in 2011 to that in 2012?
Ensure brevity in your answer.  1.02. What is the ratio of the Rating (1=extremely inefficient to 7=extremely efficient) of Other small states in 2011 to that in 2013?
Ensure brevity in your answer.  1.05. What is the ratio of the Rating (1=extremely inefficient to 7=extremely efficient) of Slovenia in 2011 to that in 2013?
Make the answer very short. 1.04. What is the ratio of the Rating (1=extremely inefficient to 7=extremely efficient) in Other small states in 2011 to that in 2014?
Your answer should be very brief. 1.05. What is the ratio of the Rating (1=extremely inefficient to 7=extremely efficient) of Kyrgyz Republic in 2011 to that in 2014?
Give a very brief answer. 0.82. What is the ratio of the Rating (1=extremely inefficient to 7=extremely efficient) of Slovenia in 2011 to that in 2014?
Provide a succinct answer. 1.02. What is the ratio of the Rating (1=extremely inefficient to 7=extremely efficient) in Kyrgyz Republic in 2012 to that in 2013?
Make the answer very short. 0.94. What is the ratio of the Rating (1=extremely inefficient to 7=extremely efficient) of Slovenia in 2012 to that in 2013?
Provide a succinct answer. 1.02. What is the ratio of the Rating (1=extremely inefficient to 7=extremely efficient) of Other small states in 2012 to that in 2014?
Offer a very short reply. 1.01. What is the ratio of the Rating (1=extremely inefficient to 7=extremely efficient) of Kyrgyz Republic in 2012 to that in 2014?
Offer a terse response. 0.88. What is the ratio of the Rating (1=extremely inefficient to 7=extremely efficient) of Slovenia in 2012 to that in 2014?
Offer a terse response. 1. What is the ratio of the Rating (1=extremely inefficient to 7=extremely efficient) of Other small states in 2013 to that in 2014?
Make the answer very short. 1. What is the ratio of the Rating (1=extremely inefficient to 7=extremely efficient) of Kyrgyz Republic in 2013 to that in 2014?
Keep it short and to the point. 0.94. What is the ratio of the Rating (1=extremely inefficient to 7=extremely efficient) in Slovenia in 2013 to that in 2014?
Your answer should be compact. 0.98. What is the difference between the highest and the second highest Rating (1=extremely inefficient to 7=extremely efficient) of Other small states?
Offer a very short reply. 0.05. What is the difference between the highest and the second highest Rating (1=extremely inefficient to 7=extremely efficient) in Kyrgyz Republic?
Ensure brevity in your answer.  0.2. What is the difference between the highest and the second highest Rating (1=extremely inefficient to 7=extremely efficient) in Slovenia?
Give a very brief answer. 0.16. What is the difference between the highest and the lowest Rating (1=extremely inefficient to 7=extremely efficient) of Other small states?
Your answer should be compact. 0.65. What is the difference between the highest and the lowest Rating (1=extremely inefficient to 7=extremely efficient) in Kyrgyz Republic?
Offer a terse response. 0.65. What is the difference between the highest and the lowest Rating (1=extremely inefficient to 7=extremely efficient) of Slovenia?
Your answer should be compact. 0.56. 